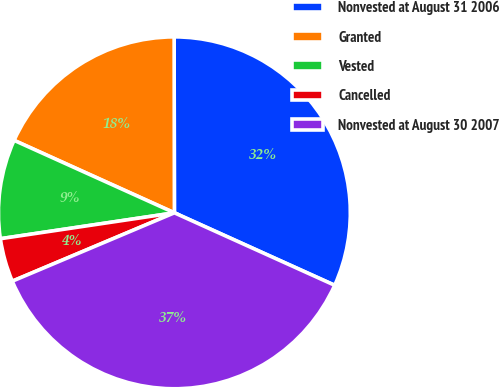Convert chart to OTSL. <chart><loc_0><loc_0><loc_500><loc_500><pie_chart><fcel>Nonvested at August 31 2006<fcel>Granted<fcel>Vested<fcel>Cancelled<fcel>Nonvested at August 30 2007<nl><fcel>31.78%<fcel>18.22%<fcel>9.11%<fcel>4.0%<fcel>36.89%<nl></chart> 